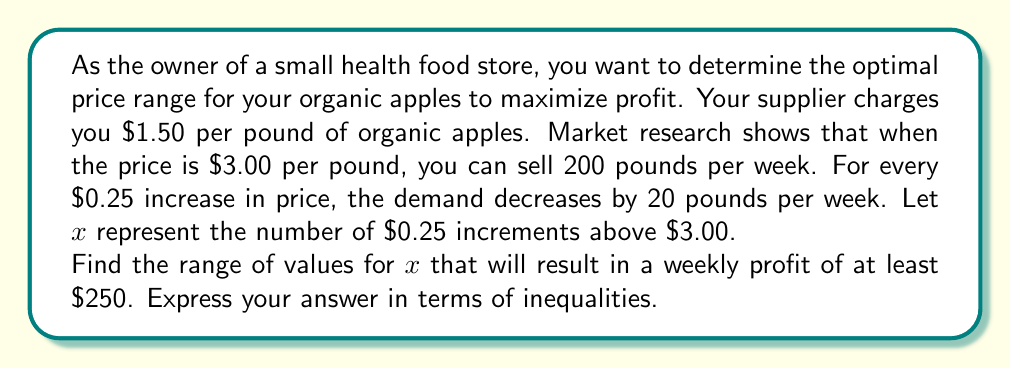Provide a solution to this math problem. Let's approach this step-by-step:

1) First, let's express the price $p$ in terms of $x$:
   $p = 3 + 0.25x$

2) Now, let's express the demand $d$ in terms of $x$:
   $d = 200 - 20x$

3) The revenue $R$ is price times demand:
   $R = pd = (3 + 0.25x)(200 - 20x) = 600 + 50x - 60x - 5x^2 = 600 - 10x - 5x^2$

4) The cost $C$ is the supplier's price times demand:
   $C = 1.50(200 - 20x) = 300 - 30x$

5) The profit $P$ is revenue minus cost:
   $P = R - C = (600 - 10x - 5x^2) - (300 - 30x) = 300 + 20x - 5x^2$

6) We want the profit to be at least $250, so:
   $300 + 20x - 5x^2 \geq 250$

7) Rearranging the inequality:
   $20x - 5x^2 \geq -50$
   $5x^2 - 20x + 50 \leq 0$

8) This is a quadratic inequality. To solve it, we need to find the roots of the quadratic equation:
   $5x^2 - 20x + 50 = 0$

9) Using the quadratic formula $\frac{-b \pm \sqrt{b^2 - 4ac}}{2a}$:
   $x = \frac{20 \pm \sqrt{400 - 1000}}{10} = \frac{20 \pm \sqrt{-600}}{10}$

10) Since the discriminant is negative, there are no real roots. This means the parabola never crosses the x-axis.

11) We can check that the inequality is satisfied when $x = 0$ (profit of $300), so the parabola is entirely below the x-axis.

12) Therefore, the inequality is satisfied for all real values of $x$.

13) However, $x$ represents the number of $0.25 increments, so it must be non-negative. Also, the price and demand must be positive, so:
    $3 + 0.25x > 0$ (always true for non-negative $x$)
    $200 - 20x > 0$
    $x < 10$

Therefore, the range of values for $x$ is $0 \leq x < 10$.
Answer: $0 \leq x < 10$ 